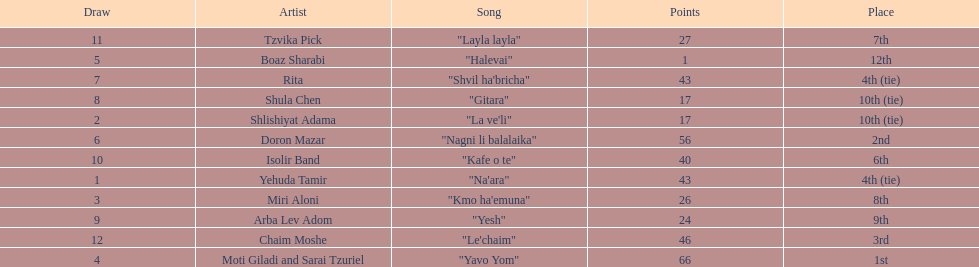Did the song "gitara" or "yesh" earn more points? "Yesh". 